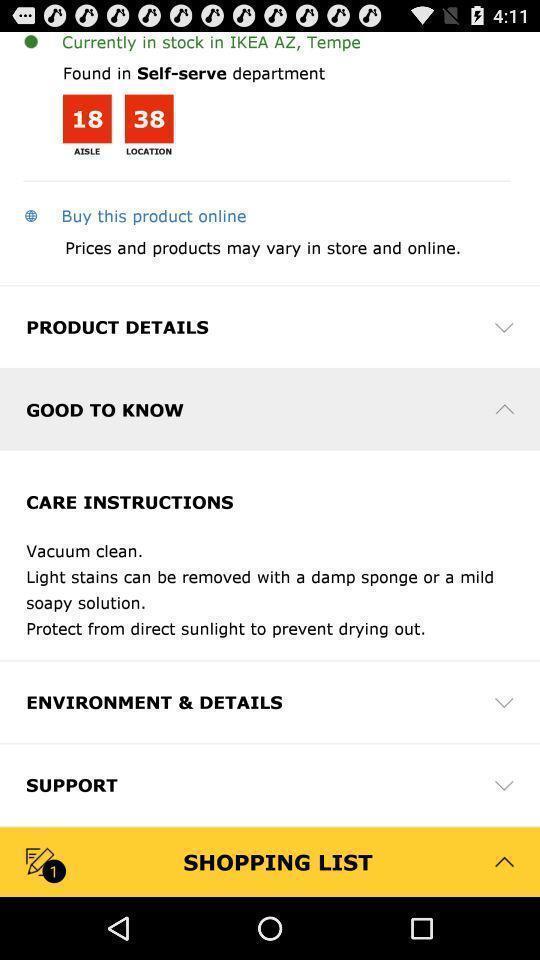Please provide a description for this image. Product details and care instructions are displaying. 